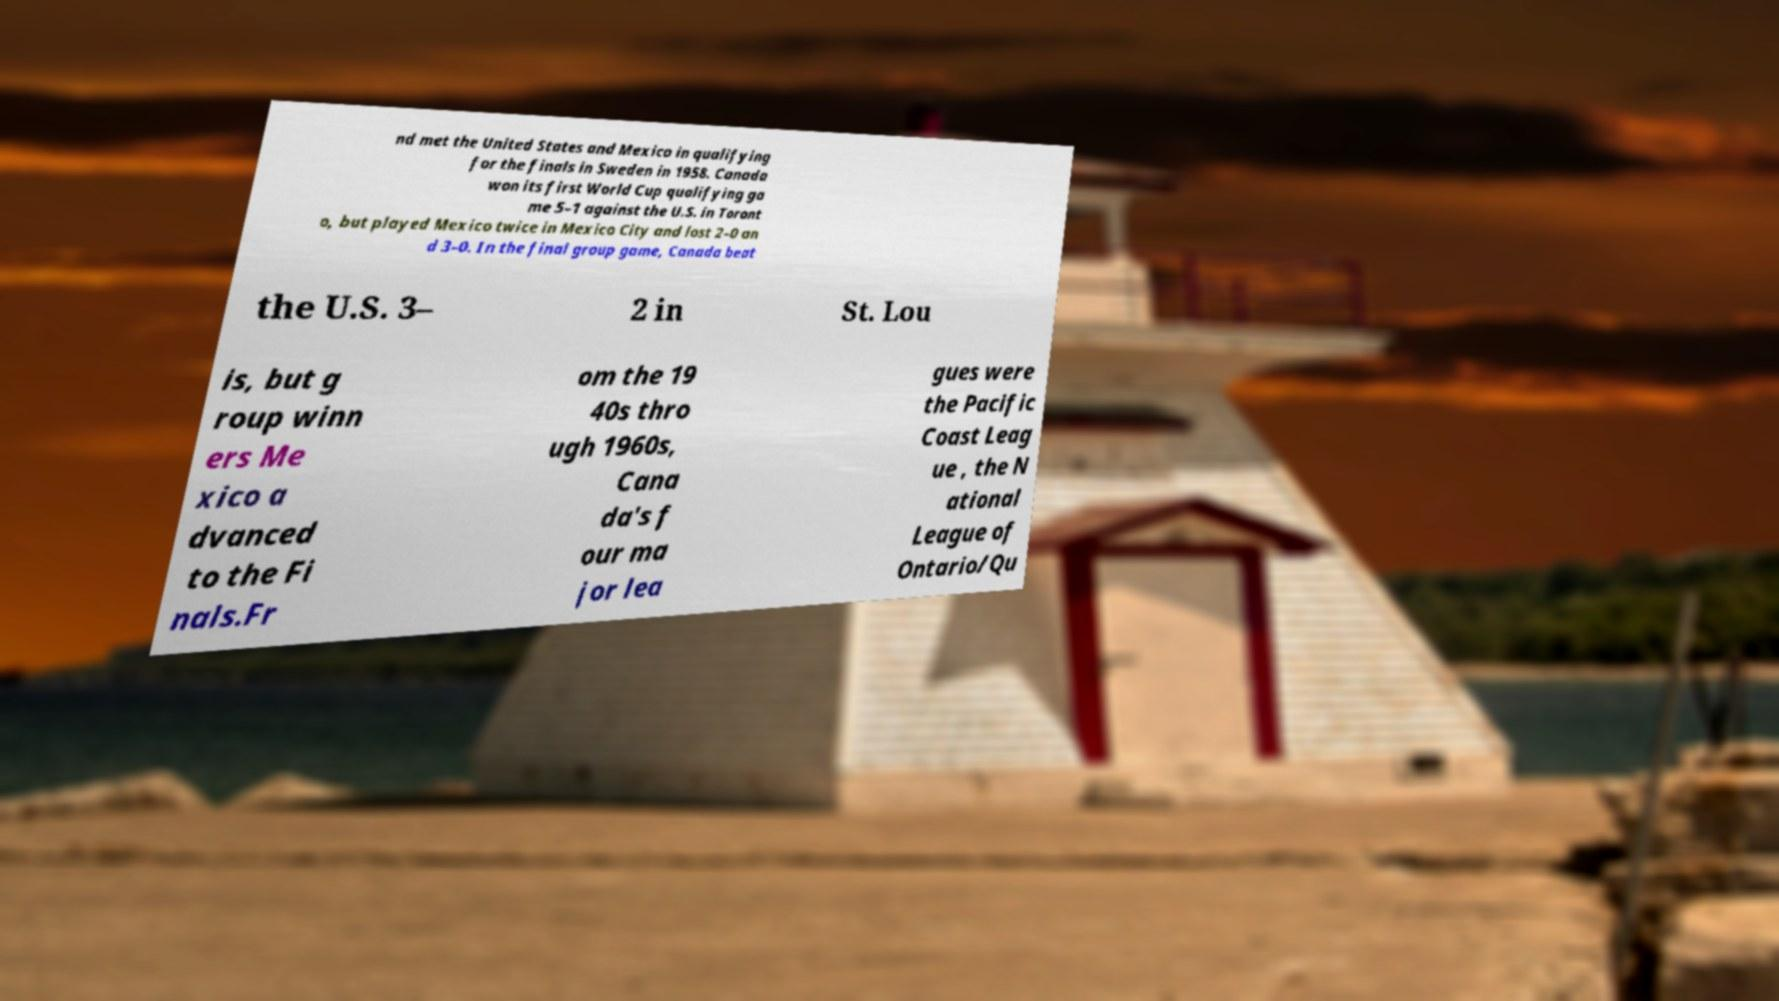Could you assist in decoding the text presented in this image and type it out clearly? nd met the United States and Mexico in qualifying for the finals in Sweden in 1958. Canada won its first World Cup qualifying ga me 5–1 against the U.S. in Toront o, but played Mexico twice in Mexico City and lost 2–0 an d 3–0. In the final group game, Canada beat the U.S. 3– 2 in St. Lou is, but g roup winn ers Me xico a dvanced to the Fi nals.Fr om the 19 40s thro ugh 1960s, Cana da's f our ma jor lea gues were the Pacific Coast Leag ue , the N ational League of Ontario/Qu 